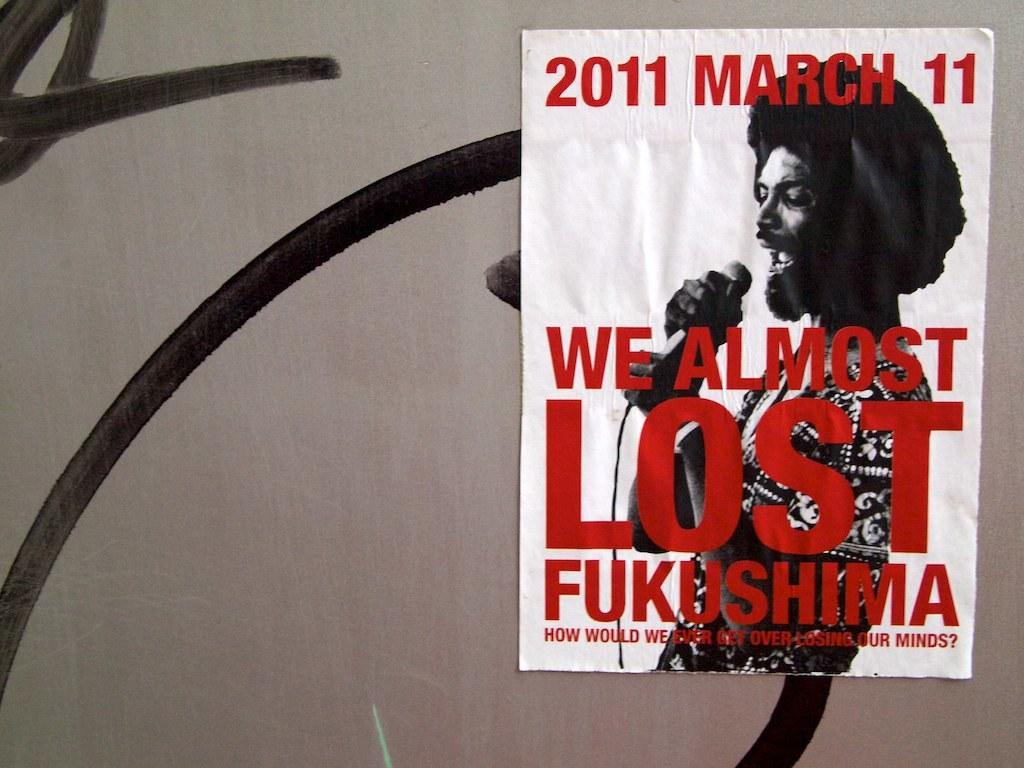<image>
Create a compact narrative representing the image presented. A poster advertises a concert that took place on March 11th, 2011. 